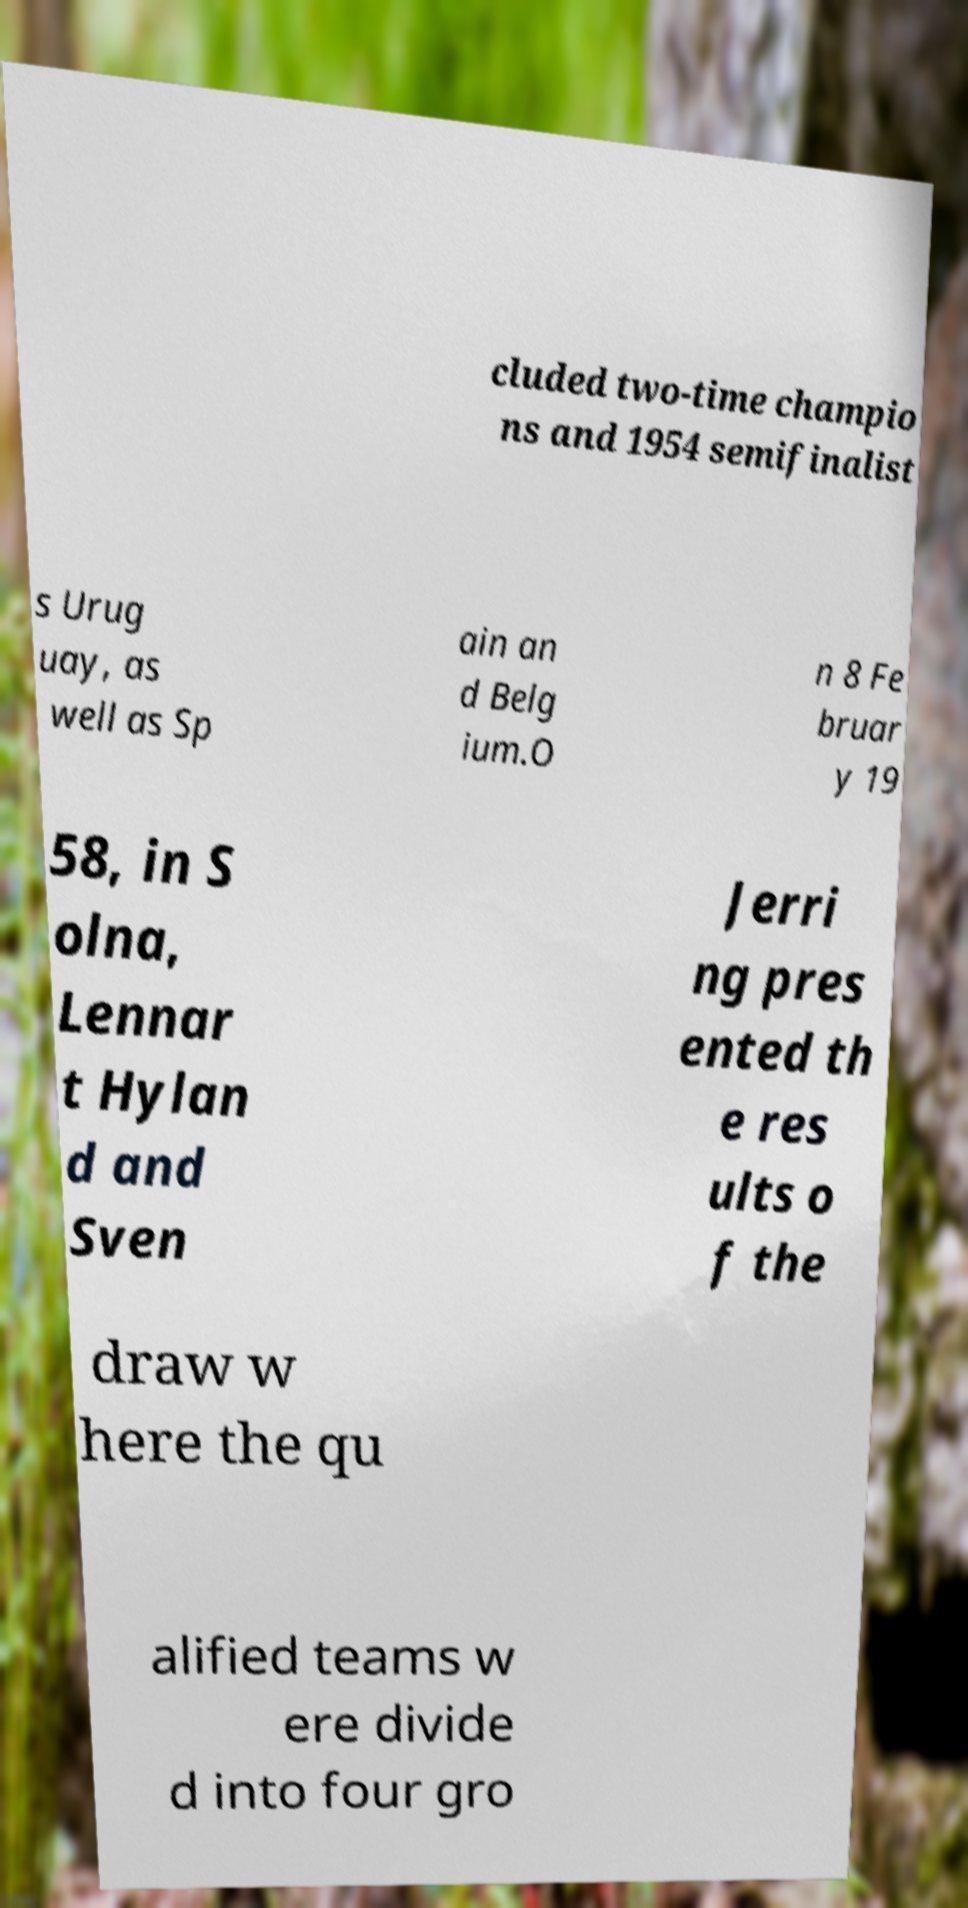What messages or text are displayed in this image? I need them in a readable, typed format. cluded two-time champio ns and 1954 semifinalist s Urug uay, as well as Sp ain an d Belg ium.O n 8 Fe bruar y 19 58, in S olna, Lennar t Hylan d and Sven Jerri ng pres ented th e res ults o f the draw w here the qu alified teams w ere divide d into four gro 